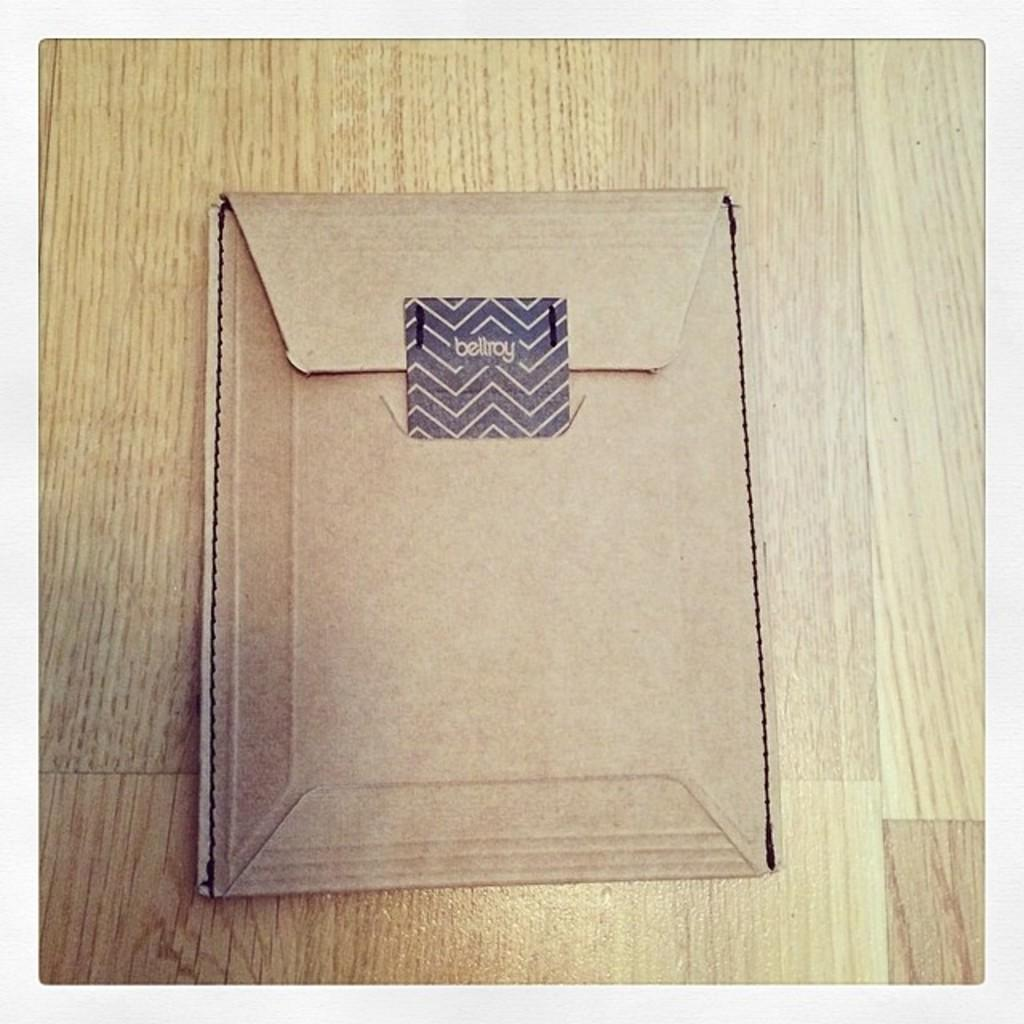<image>
Provide a brief description of the given image. A cardboard box that has tape on it that says bellroy 